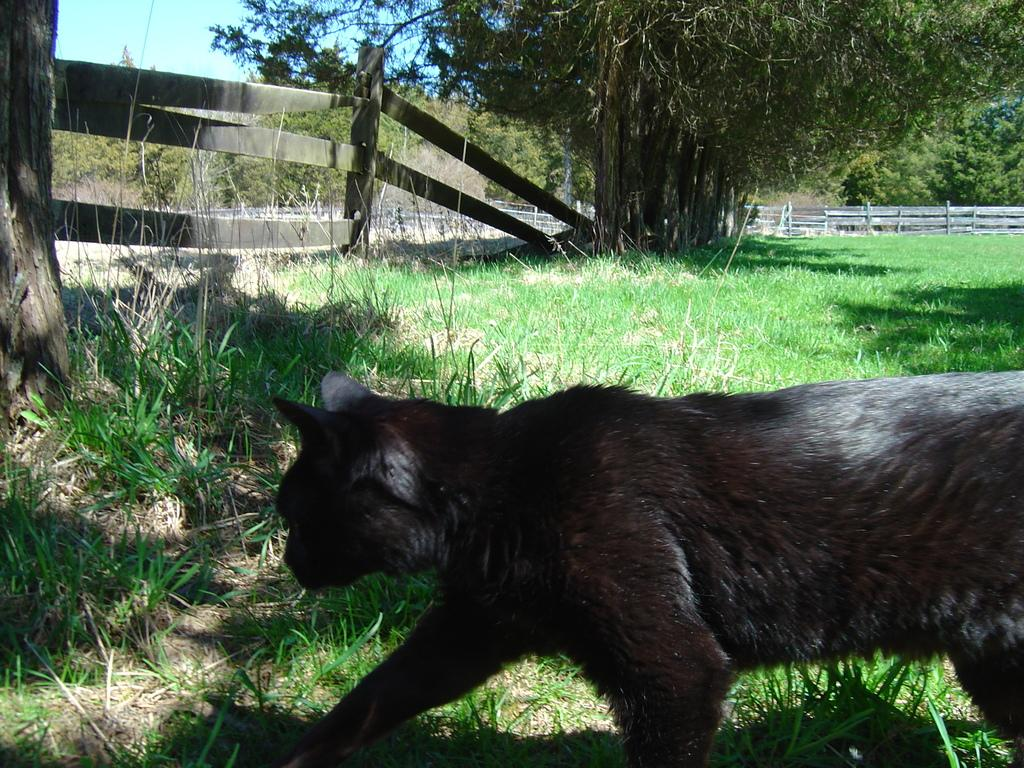What type of animal can be seen on the ground in the image? The specific type of animal cannot be determined from the image, but there is an animal on the ground. What kind of barrier is present in the image? There is a wooden fence in the image. What type of vegetation is visible in the image? There is grass in the image. What other natural elements can be seen in the image? There are trees in the image. What is visible in the background of the image? The sky is visible in the background of the image. What type of lace is being used by the animal in the image? There is no lace present in the image, and the animal is not performing any activities that would involve lace. 